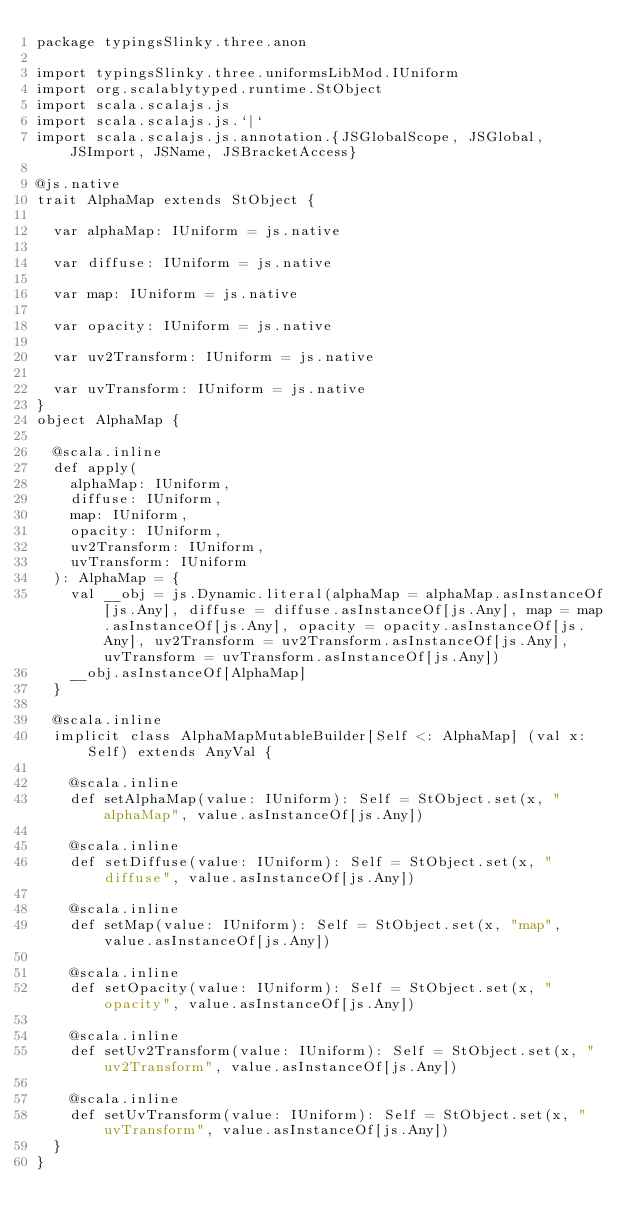Convert code to text. <code><loc_0><loc_0><loc_500><loc_500><_Scala_>package typingsSlinky.three.anon

import typingsSlinky.three.uniformsLibMod.IUniform
import org.scalablytyped.runtime.StObject
import scala.scalajs.js
import scala.scalajs.js.`|`
import scala.scalajs.js.annotation.{JSGlobalScope, JSGlobal, JSImport, JSName, JSBracketAccess}

@js.native
trait AlphaMap extends StObject {
  
  var alphaMap: IUniform = js.native
  
  var diffuse: IUniform = js.native
  
  var map: IUniform = js.native
  
  var opacity: IUniform = js.native
  
  var uv2Transform: IUniform = js.native
  
  var uvTransform: IUniform = js.native
}
object AlphaMap {
  
  @scala.inline
  def apply(
    alphaMap: IUniform,
    diffuse: IUniform,
    map: IUniform,
    opacity: IUniform,
    uv2Transform: IUniform,
    uvTransform: IUniform
  ): AlphaMap = {
    val __obj = js.Dynamic.literal(alphaMap = alphaMap.asInstanceOf[js.Any], diffuse = diffuse.asInstanceOf[js.Any], map = map.asInstanceOf[js.Any], opacity = opacity.asInstanceOf[js.Any], uv2Transform = uv2Transform.asInstanceOf[js.Any], uvTransform = uvTransform.asInstanceOf[js.Any])
    __obj.asInstanceOf[AlphaMap]
  }
  
  @scala.inline
  implicit class AlphaMapMutableBuilder[Self <: AlphaMap] (val x: Self) extends AnyVal {
    
    @scala.inline
    def setAlphaMap(value: IUniform): Self = StObject.set(x, "alphaMap", value.asInstanceOf[js.Any])
    
    @scala.inline
    def setDiffuse(value: IUniform): Self = StObject.set(x, "diffuse", value.asInstanceOf[js.Any])
    
    @scala.inline
    def setMap(value: IUniform): Self = StObject.set(x, "map", value.asInstanceOf[js.Any])
    
    @scala.inline
    def setOpacity(value: IUniform): Self = StObject.set(x, "opacity", value.asInstanceOf[js.Any])
    
    @scala.inline
    def setUv2Transform(value: IUniform): Self = StObject.set(x, "uv2Transform", value.asInstanceOf[js.Any])
    
    @scala.inline
    def setUvTransform(value: IUniform): Self = StObject.set(x, "uvTransform", value.asInstanceOf[js.Any])
  }
}
</code> 